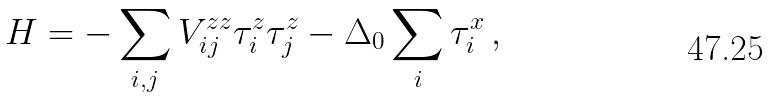<formula> <loc_0><loc_0><loc_500><loc_500>H = - \sum _ { i , j } V _ { i j } ^ { z z } \tau _ { i } ^ { z } \tau _ { j } ^ { z } - \Delta _ { 0 } \sum _ { i } \tau _ { i } ^ { x } \, ,</formula> 